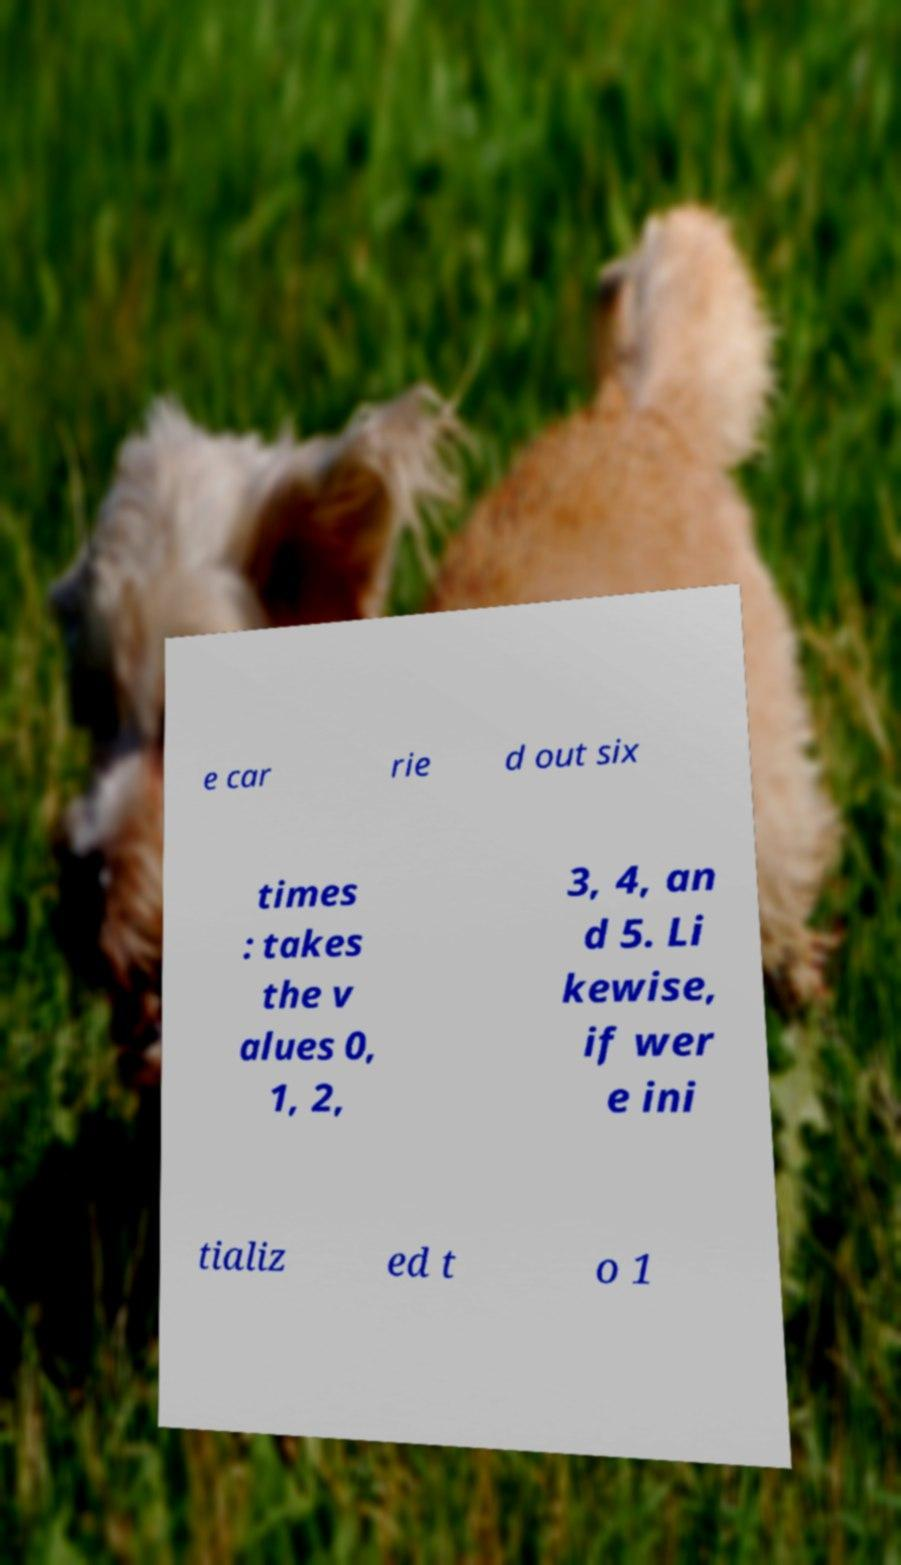There's text embedded in this image that I need extracted. Can you transcribe it verbatim? e car rie d out six times : takes the v alues 0, 1, 2, 3, 4, an d 5. Li kewise, if wer e ini tializ ed t o 1 